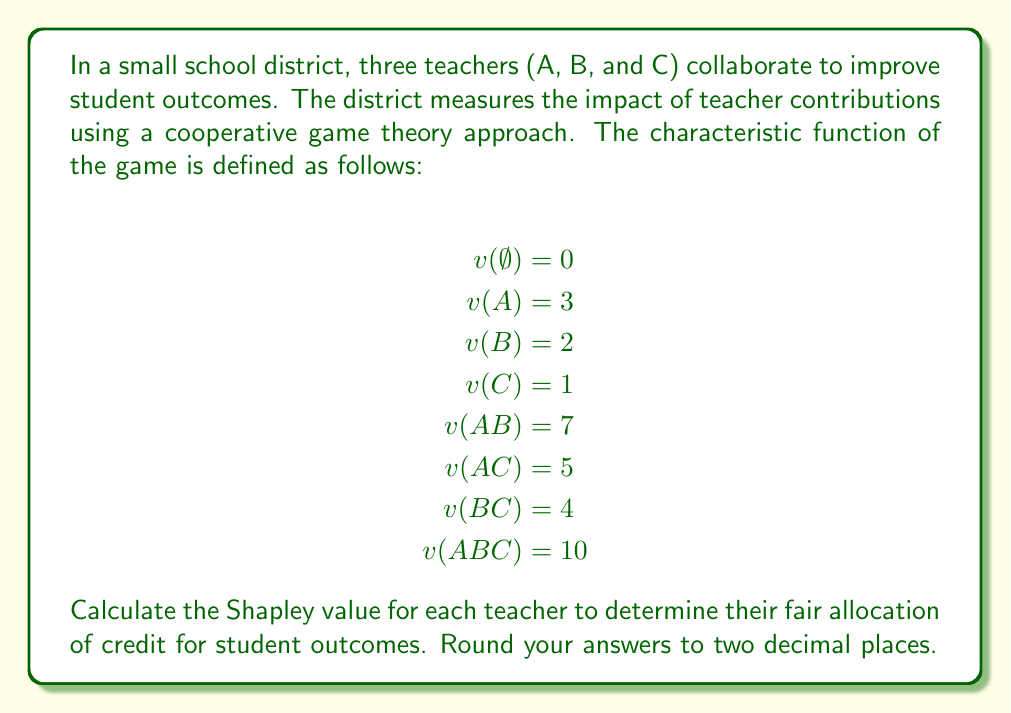Help me with this question. To calculate the Shapley value for each teacher, we need to follow these steps:

1. List all possible permutations of the teachers.
2. For each permutation, calculate the marginal contribution of each teacher.
3. Average the marginal contributions for each teacher across all permutations.

Step 1: List all permutations
1. ABC
2. ACB
3. BAC
4. BCA
5. CAB
6. CBA

Step 2: Calculate marginal contributions

For ABC:
A: $v(A) - v(\emptyset) = 3 - 0 = 3$
B: $v(AB) - v(A) = 7 - 3 = 4$
C: $v(ABC) - v(AB) = 10 - 7 = 3$

For ACB:
A: $v(A) - v(\emptyset) = 3 - 0 = 3$
C: $v(AC) - v(A) = 5 - 3 = 2$
B: $v(ABC) - v(AC) = 10 - 5 = 5$

For BAC:
B: $v(B) - v(\emptyset) = 2 - 0 = 2$
A: $v(AB) - v(B) = 7 - 2 = 5$
C: $v(ABC) - v(AB) = 10 - 7 = 3$

For BCA:
B: $v(B) - v(\emptyset) = 2 - 0 = 2$
C: $v(BC) - v(B) = 4 - 2 = 2$
A: $v(ABC) - v(BC) = 10 - 4 = 6$

For CAB:
C: $v(C) - v(\emptyset) = 1 - 0 = 1$
A: $v(AC) - v(C) = 5 - 1 = 4$
B: $v(ABC) - v(AC) = 10 - 5 = 5$

For CBA:
C: $v(C) - v(\emptyset) = 1 - 0 = 1$
B: $v(BC) - v(C) = 4 - 1 = 3$
A: $v(ABC) - v(BC) = 10 - 4 = 6$

Step 3: Average the marginal contributions

Teacher A: $\frac{3 + 3 + 5 + 6 + 4 + 6}{6} = \frac{27}{6} = 4.5$

Teacher B: $\frac{4 + 5 + 2 + 2 + 5 + 3}{6} = \frac{21}{6} = 3.5$

Teacher C: $\frac{3 + 2 + 3 + 2 + 1 + 1}{6} = \frac{12}{6} = 2$

The Shapley value represents the fair allocation of credit for each teacher's contribution to student outcomes.
Answer: The Shapley values for the teachers are:

Teacher A: 4.50
Teacher B: 3.50
Teacher C: 2.00 